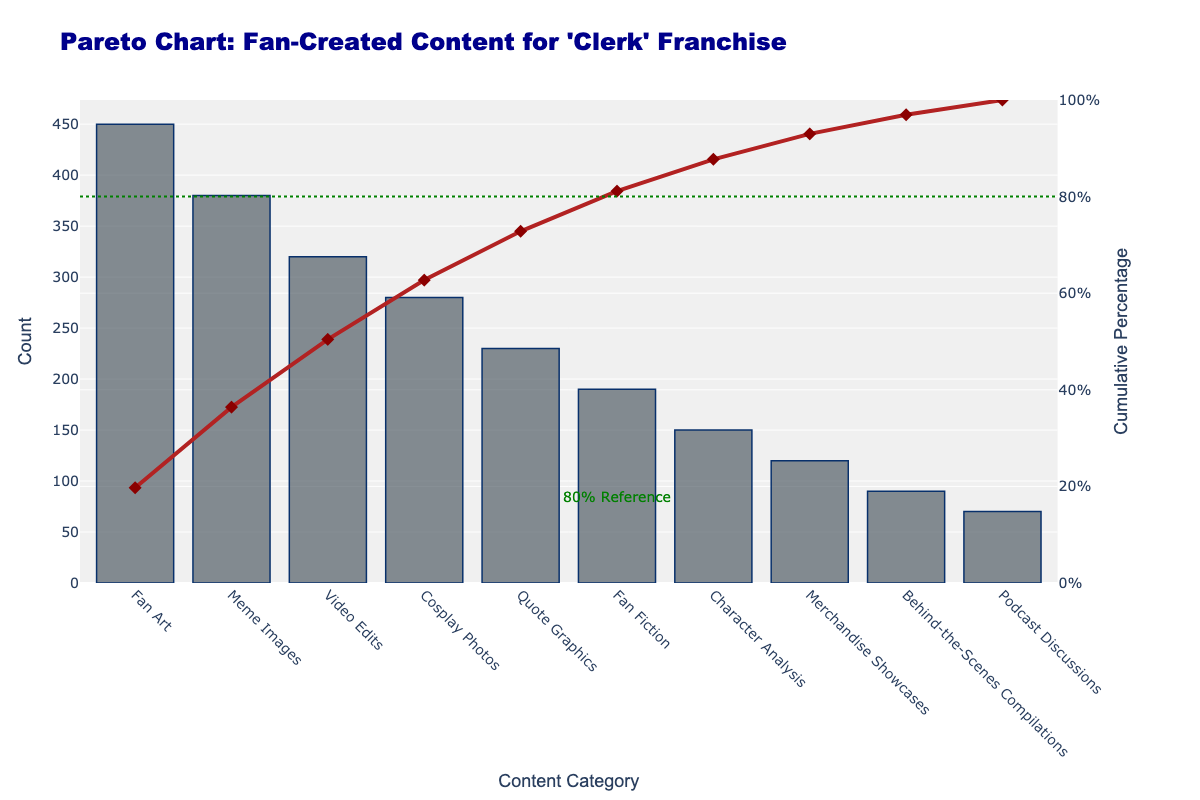What's the title of the chart? The title of the chart is displayed at the top and reads "Pareto Chart: Fan-Created Content for 'Clerk' Franchise".
Answer: Pareto Chart: Fan-Created Content for 'Clerk' Franchise Which content category has the highest count? The highest bar represents the "Fan Art" category with a count of 450.
Answer: Fan Art What is the cumulative percentage for Fan Art and Meme Images combined? "Fan Art" has a count of 450, and "Meme Images" has a count of 380. Their combined count is 450 + 380 = 830. The total count for all categories is 2,280. The cumulative percentage is calculated as (830 / 2280) * 100 ≈ 36.4%.
Answer: 36.4% Which category contributes to reaching the 80% cumulative percentage milestone? The cumulative percentage for Category Analysis stops approximately at 80%, making it the category that contributes to reaching this milestone.
Answer: Character Analysis How many types of content categories are listed in the chart? By counting the bars on the x-axis, we can see there are 10 different content categories listed in the chart.
Answer: 10 Compare the count of Fan Art to Video Edits. How much greater is the Fan Art count? The "Fan Art" count is 450, and the "Video Edits" count is 320. To find how much greater, subtract the "Video Edits" count from the "Fan Art" count: 450 - 320 = 130.
Answer: 130 What's the count for Cosplay Photos, and how does it compare to Quote Graphics? The count for "Cosplay Photos" is 280, and "Quote Graphics" is 230. "Cosplay Photos" is greater than "Quote Graphics" by 280 - 230 = 50.
Answer: 50 more What cumulative percentage is achieved after including Quote Graphics? The categories up to "Quote Graphics" are: "Fan Art" (450), "Meme Images" (380), "Video Edits" (320), "Cosplay Photos" (280), and "Quote Graphics" (230). Summing these gives 450 + 380 + 320 + 280 + 230 = 1660. The cumulative percentage is (1660 / 2280) * 100 ≈ 72.8%.
Answer: 72.8% By how much does the count of Cosplay Photos exceed Podcast Discussions? The count for "Cosplay Photos" is 280, and for "Podcast Discussions" it is 70. The difference is 280 - 70 = 210.
Answer: 210 What's the count difference between the lowest and highest counted content categories? The highest count is "Fan Art" with 450, and the lowest is "Podcast Discussions" with 70. The difference is 450 - 70 = 380.
Answer: 380 